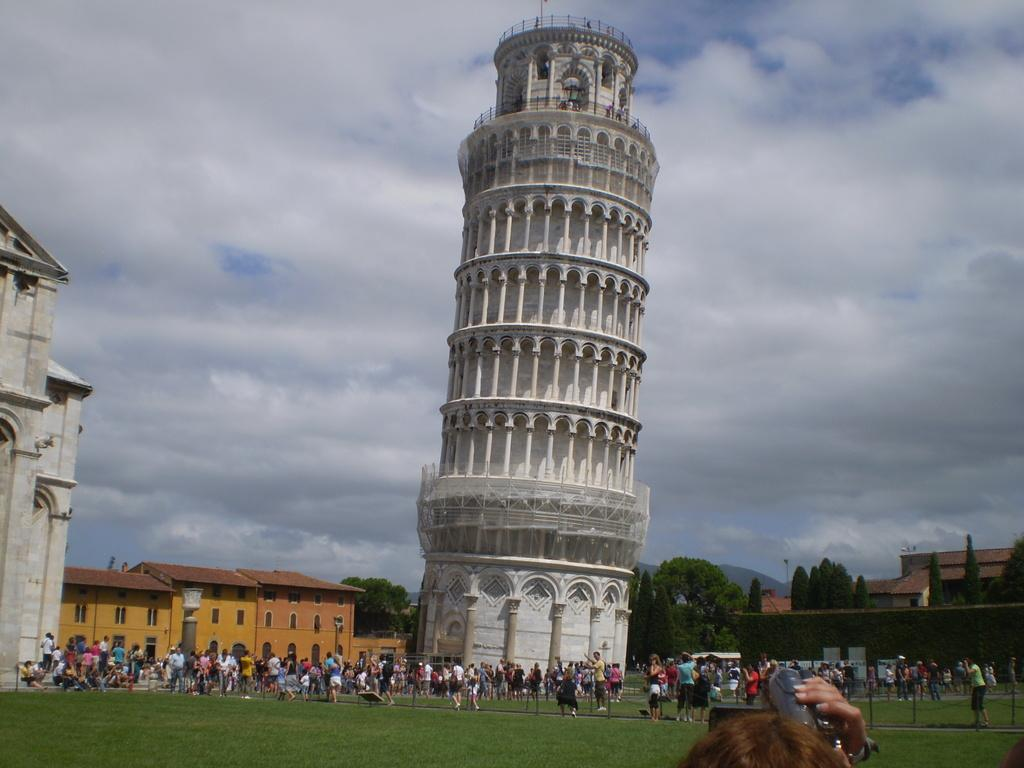How many people are in the image? There are people in the image, but the exact number is not specified. What are the people doing in the image? The people are doing different activities in the image. Where are these activities taking place? The activities are taking place on a grassland. What can be seen in the background of the image? In the background of the image, there are houses, a tower, trees, and the sky. What type of mask is being worn by the person in the image? There is no mention of a mask in the image. Can you see a bag in the image? There is no mention of a bag in the image. 